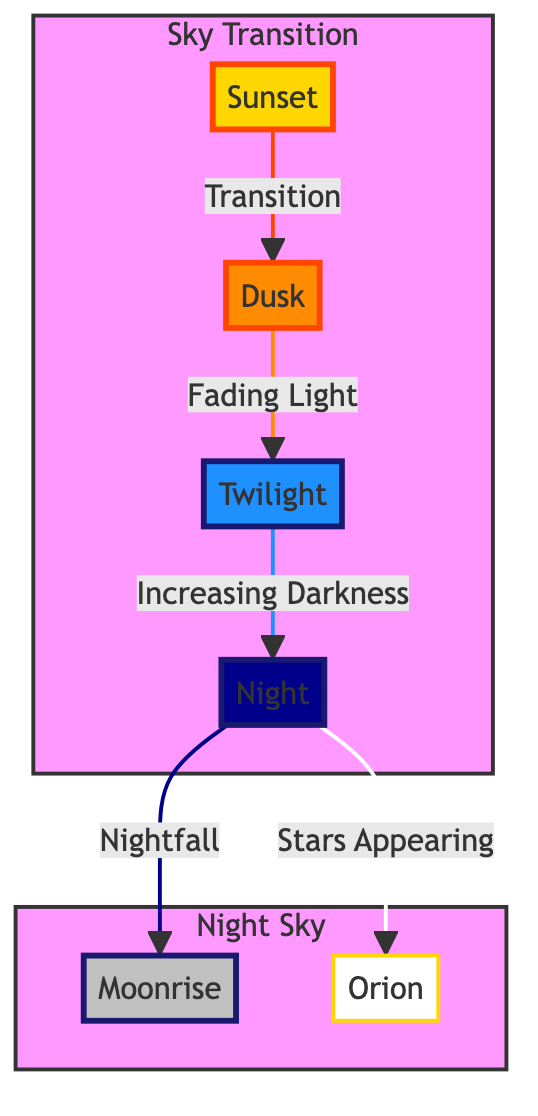What's the first stage of the transition from day to night? The diagram's flow indicates that the first stage is 'Sunset'. It is the first node in the sequence representing the transition.
Answer: Sunset How many stages are shown in the transition from day to night? The diagram shows four stages: Sunset, Dusk, Twilight, and Night. Counting each stage clearly indicates there are four distinct nodes in the transition.
Answer: 4 Which stage follows 'Dusk' in the transition sequence? The diagram indicates that 'Twilight' is the stage that directly follows 'Dusk'. This can be observed by the directional link between the two stages.
Answer: Twilight What color represents the 'Night' stage? The 'Night' stage is represented by a dark blue color, specifically #00008B, as indicated in the diagram's class definitions.
Answer: Dark Blue At what stage do the stars begin to appear? According to the diagram, stars begin to appear during the 'Night' stage. The node directly states this occurrence.
Answer: Night What is the relationship between 'Night' and 'Moonrise'? In the diagram, 'Night' transitions directly to 'Moonrise', indicating that after reaching the 'Night' stage, the moonrise event occurs.
Answer: Transition Which constellation is marked in the night sky? The diagram indicates 'Orion' as the notable constellation in the 'Night' sky section, as it is connected with a line from the 'Night' node.
Answer: Orion Which two stages share the same color gradient in the diagram? The stages 'Dusk' and 'Twilight' share a similar orange color gradient, as illustrated in the class definitions assigned to those nodes.
Answer: Dusk and Twilight What visual feature indicates the fading light during the transition? The visual feature representing fading light is the link from 'Dusk' to 'Twilight', labeled 'Fading Light', which conveys the gradual change in illumination as day shifts to night.
Answer: Fading Light 